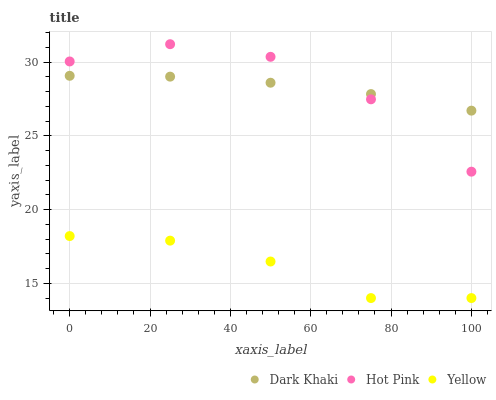Does Yellow have the minimum area under the curve?
Answer yes or no. Yes. Does Hot Pink have the maximum area under the curve?
Answer yes or no. Yes. Does Hot Pink have the minimum area under the curve?
Answer yes or no. No. Does Yellow have the maximum area under the curve?
Answer yes or no. No. Is Dark Khaki the smoothest?
Answer yes or no. Yes. Is Hot Pink the roughest?
Answer yes or no. Yes. Is Yellow the smoothest?
Answer yes or no. No. Is Yellow the roughest?
Answer yes or no. No. Does Yellow have the lowest value?
Answer yes or no. Yes. Does Hot Pink have the lowest value?
Answer yes or no. No. Does Hot Pink have the highest value?
Answer yes or no. Yes. Does Yellow have the highest value?
Answer yes or no. No. Is Yellow less than Dark Khaki?
Answer yes or no. Yes. Is Hot Pink greater than Yellow?
Answer yes or no. Yes. Does Dark Khaki intersect Hot Pink?
Answer yes or no. Yes. Is Dark Khaki less than Hot Pink?
Answer yes or no. No. Is Dark Khaki greater than Hot Pink?
Answer yes or no. No. Does Yellow intersect Dark Khaki?
Answer yes or no. No. 